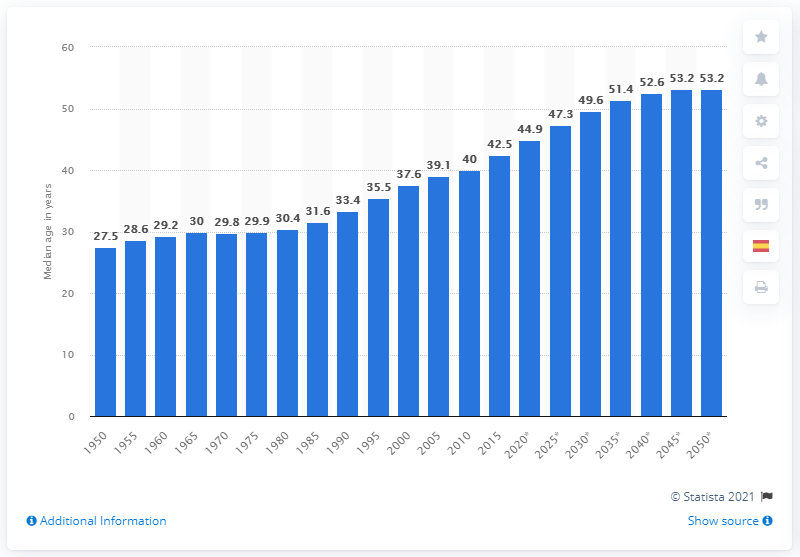List a handful of essential elements in this visual. In 1950, Spain's median age was 27.5 years old. 